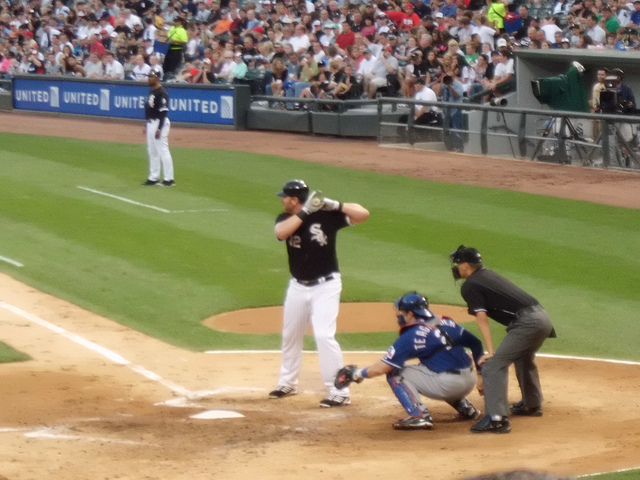Read and extract the text from this image. UNITED UNITED UNITED TEAG UNITE 